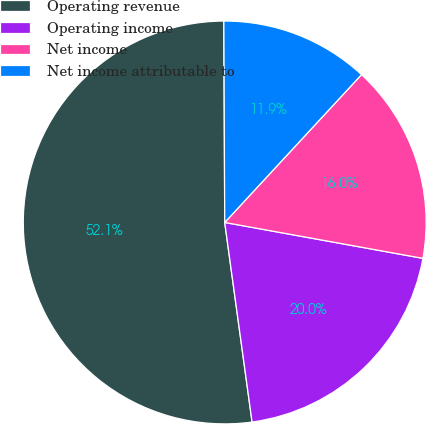<chart> <loc_0><loc_0><loc_500><loc_500><pie_chart><fcel>Operating revenue<fcel>Operating income<fcel>Net income<fcel>Net income attributable to<nl><fcel>52.1%<fcel>19.98%<fcel>15.97%<fcel>11.95%<nl></chart> 